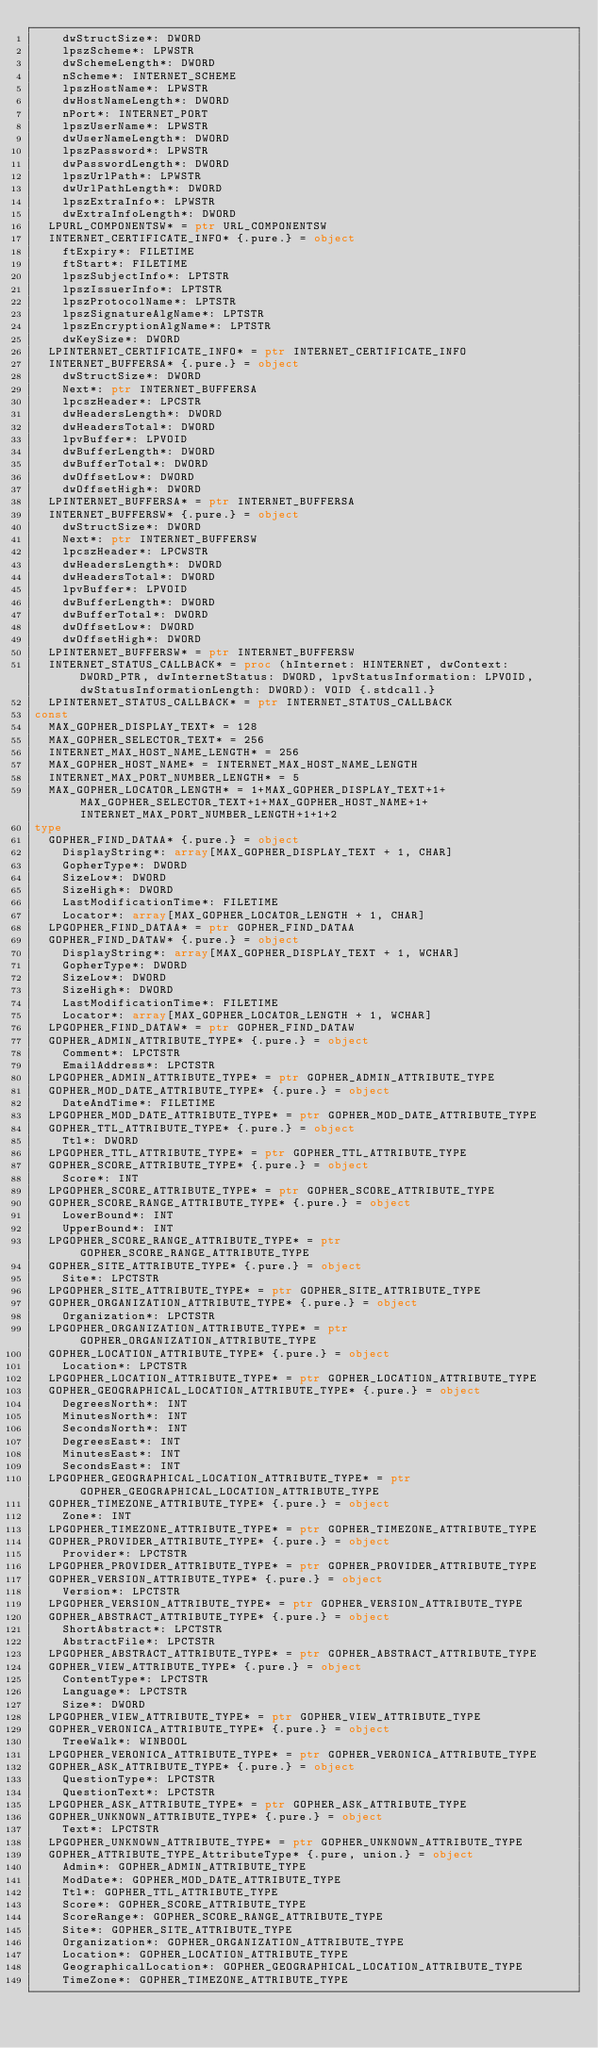<code> <loc_0><loc_0><loc_500><loc_500><_Nim_>    dwStructSize*: DWORD
    lpszScheme*: LPWSTR
    dwSchemeLength*: DWORD
    nScheme*: INTERNET_SCHEME
    lpszHostName*: LPWSTR
    dwHostNameLength*: DWORD
    nPort*: INTERNET_PORT
    lpszUserName*: LPWSTR
    dwUserNameLength*: DWORD
    lpszPassword*: LPWSTR
    dwPasswordLength*: DWORD
    lpszUrlPath*: LPWSTR
    dwUrlPathLength*: DWORD
    lpszExtraInfo*: LPWSTR
    dwExtraInfoLength*: DWORD
  LPURL_COMPONENTSW* = ptr URL_COMPONENTSW
  INTERNET_CERTIFICATE_INFO* {.pure.} = object
    ftExpiry*: FILETIME
    ftStart*: FILETIME
    lpszSubjectInfo*: LPTSTR
    lpszIssuerInfo*: LPTSTR
    lpszProtocolName*: LPTSTR
    lpszSignatureAlgName*: LPTSTR
    lpszEncryptionAlgName*: LPTSTR
    dwKeySize*: DWORD
  LPINTERNET_CERTIFICATE_INFO* = ptr INTERNET_CERTIFICATE_INFO
  INTERNET_BUFFERSA* {.pure.} = object
    dwStructSize*: DWORD
    Next*: ptr INTERNET_BUFFERSA
    lpcszHeader*: LPCSTR
    dwHeadersLength*: DWORD
    dwHeadersTotal*: DWORD
    lpvBuffer*: LPVOID
    dwBufferLength*: DWORD
    dwBufferTotal*: DWORD
    dwOffsetLow*: DWORD
    dwOffsetHigh*: DWORD
  LPINTERNET_BUFFERSA* = ptr INTERNET_BUFFERSA
  INTERNET_BUFFERSW* {.pure.} = object
    dwStructSize*: DWORD
    Next*: ptr INTERNET_BUFFERSW
    lpcszHeader*: LPCWSTR
    dwHeadersLength*: DWORD
    dwHeadersTotal*: DWORD
    lpvBuffer*: LPVOID
    dwBufferLength*: DWORD
    dwBufferTotal*: DWORD
    dwOffsetLow*: DWORD
    dwOffsetHigh*: DWORD
  LPINTERNET_BUFFERSW* = ptr INTERNET_BUFFERSW
  INTERNET_STATUS_CALLBACK* = proc (hInternet: HINTERNET, dwContext: DWORD_PTR, dwInternetStatus: DWORD, lpvStatusInformation: LPVOID, dwStatusInformationLength: DWORD): VOID {.stdcall.}
  LPINTERNET_STATUS_CALLBACK* = ptr INTERNET_STATUS_CALLBACK
const
  MAX_GOPHER_DISPLAY_TEXT* = 128
  MAX_GOPHER_SELECTOR_TEXT* = 256
  INTERNET_MAX_HOST_NAME_LENGTH* = 256
  MAX_GOPHER_HOST_NAME* = INTERNET_MAX_HOST_NAME_LENGTH
  INTERNET_MAX_PORT_NUMBER_LENGTH* = 5
  MAX_GOPHER_LOCATOR_LENGTH* = 1+MAX_GOPHER_DISPLAY_TEXT+1+MAX_GOPHER_SELECTOR_TEXT+1+MAX_GOPHER_HOST_NAME+1+INTERNET_MAX_PORT_NUMBER_LENGTH+1+1+2
type
  GOPHER_FIND_DATAA* {.pure.} = object
    DisplayString*: array[MAX_GOPHER_DISPLAY_TEXT + 1, CHAR]
    GopherType*: DWORD
    SizeLow*: DWORD
    SizeHigh*: DWORD
    LastModificationTime*: FILETIME
    Locator*: array[MAX_GOPHER_LOCATOR_LENGTH + 1, CHAR]
  LPGOPHER_FIND_DATAA* = ptr GOPHER_FIND_DATAA
  GOPHER_FIND_DATAW* {.pure.} = object
    DisplayString*: array[MAX_GOPHER_DISPLAY_TEXT + 1, WCHAR]
    GopherType*: DWORD
    SizeLow*: DWORD
    SizeHigh*: DWORD
    LastModificationTime*: FILETIME
    Locator*: array[MAX_GOPHER_LOCATOR_LENGTH + 1, WCHAR]
  LPGOPHER_FIND_DATAW* = ptr GOPHER_FIND_DATAW
  GOPHER_ADMIN_ATTRIBUTE_TYPE* {.pure.} = object
    Comment*: LPCTSTR
    EmailAddress*: LPCTSTR
  LPGOPHER_ADMIN_ATTRIBUTE_TYPE* = ptr GOPHER_ADMIN_ATTRIBUTE_TYPE
  GOPHER_MOD_DATE_ATTRIBUTE_TYPE* {.pure.} = object
    DateAndTime*: FILETIME
  LPGOPHER_MOD_DATE_ATTRIBUTE_TYPE* = ptr GOPHER_MOD_DATE_ATTRIBUTE_TYPE
  GOPHER_TTL_ATTRIBUTE_TYPE* {.pure.} = object
    Ttl*: DWORD
  LPGOPHER_TTL_ATTRIBUTE_TYPE* = ptr GOPHER_TTL_ATTRIBUTE_TYPE
  GOPHER_SCORE_ATTRIBUTE_TYPE* {.pure.} = object
    Score*: INT
  LPGOPHER_SCORE_ATTRIBUTE_TYPE* = ptr GOPHER_SCORE_ATTRIBUTE_TYPE
  GOPHER_SCORE_RANGE_ATTRIBUTE_TYPE* {.pure.} = object
    LowerBound*: INT
    UpperBound*: INT
  LPGOPHER_SCORE_RANGE_ATTRIBUTE_TYPE* = ptr GOPHER_SCORE_RANGE_ATTRIBUTE_TYPE
  GOPHER_SITE_ATTRIBUTE_TYPE* {.pure.} = object
    Site*: LPCTSTR
  LPGOPHER_SITE_ATTRIBUTE_TYPE* = ptr GOPHER_SITE_ATTRIBUTE_TYPE
  GOPHER_ORGANIZATION_ATTRIBUTE_TYPE* {.pure.} = object
    Organization*: LPCTSTR
  LPGOPHER_ORGANIZATION_ATTRIBUTE_TYPE* = ptr GOPHER_ORGANIZATION_ATTRIBUTE_TYPE
  GOPHER_LOCATION_ATTRIBUTE_TYPE* {.pure.} = object
    Location*: LPCTSTR
  LPGOPHER_LOCATION_ATTRIBUTE_TYPE* = ptr GOPHER_LOCATION_ATTRIBUTE_TYPE
  GOPHER_GEOGRAPHICAL_LOCATION_ATTRIBUTE_TYPE* {.pure.} = object
    DegreesNorth*: INT
    MinutesNorth*: INT
    SecondsNorth*: INT
    DegreesEast*: INT
    MinutesEast*: INT
    SecondsEast*: INT
  LPGOPHER_GEOGRAPHICAL_LOCATION_ATTRIBUTE_TYPE* = ptr GOPHER_GEOGRAPHICAL_LOCATION_ATTRIBUTE_TYPE
  GOPHER_TIMEZONE_ATTRIBUTE_TYPE* {.pure.} = object
    Zone*: INT
  LPGOPHER_TIMEZONE_ATTRIBUTE_TYPE* = ptr GOPHER_TIMEZONE_ATTRIBUTE_TYPE
  GOPHER_PROVIDER_ATTRIBUTE_TYPE* {.pure.} = object
    Provider*: LPCTSTR
  LPGOPHER_PROVIDER_ATTRIBUTE_TYPE* = ptr GOPHER_PROVIDER_ATTRIBUTE_TYPE
  GOPHER_VERSION_ATTRIBUTE_TYPE* {.pure.} = object
    Version*: LPCTSTR
  LPGOPHER_VERSION_ATTRIBUTE_TYPE* = ptr GOPHER_VERSION_ATTRIBUTE_TYPE
  GOPHER_ABSTRACT_ATTRIBUTE_TYPE* {.pure.} = object
    ShortAbstract*: LPCTSTR
    AbstractFile*: LPCTSTR
  LPGOPHER_ABSTRACT_ATTRIBUTE_TYPE* = ptr GOPHER_ABSTRACT_ATTRIBUTE_TYPE
  GOPHER_VIEW_ATTRIBUTE_TYPE* {.pure.} = object
    ContentType*: LPCTSTR
    Language*: LPCTSTR
    Size*: DWORD
  LPGOPHER_VIEW_ATTRIBUTE_TYPE* = ptr GOPHER_VIEW_ATTRIBUTE_TYPE
  GOPHER_VERONICA_ATTRIBUTE_TYPE* {.pure.} = object
    TreeWalk*: WINBOOL
  LPGOPHER_VERONICA_ATTRIBUTE_TYPE* = ptr GOPHER_VERONICA_ATTRIBUTE_TYPE
  GOPHER_ASK_ATTRIBUTE_TYPE* {.pure.} = object
    QuestionType*: LPCTSTR
    QuestionText*: LPCTSTR
  LPGOPHER_ASK_ATTRIBUTE_TYPE* = ptr GOPHER_ASK_ATTRIBUTE_TYPE
  GOPHER_UNKNOWN_ATTRIBUTE_TYPE* {.pure.} = object
    Text*: LPCTSTR
  LPGOPHER_UNKNOWN_ATTRIBUTE_TYPE* = ptr GOPHER_UNKNOWN_ATTRIBUTE_TYPE
  GOPHER_ATTRIBUTE_TYPE_AttributeType* {.pure, union.} = object
    Admin*: GOPHER_ADMIN_ATTRIBUTE_TYPE
    ModDate*: GOPHER_MOD_DATE_ATTRIBUTE_TYPE
    Ttl*: GOPHER_TTL_ATTRIBUTE_TYPE
    Score*: GOPHER_SCORE_ATTRIBUTE_TYPE
    ScoreRange*: GOPHER_SCORE_RANGE_ATTRIBUTE_TYPE
    Site*: GOPHER_SITE_ATTRIBUTE_TYPE
    Organization*: GOPHER_ORGANIZATION_ATTRIBUTE_TYPE
    Location*: GOPHER_LOCATION_ATTRIBUTE_TYPE
    GeographicalLocation*: GOPHER_GEOGRAPHICAL_LOCATION_ATTRIBUTE_TYPE
    TimeZone*: GOPHER_TIMEZONE_ATTRIBUTE_TYPE</code> 